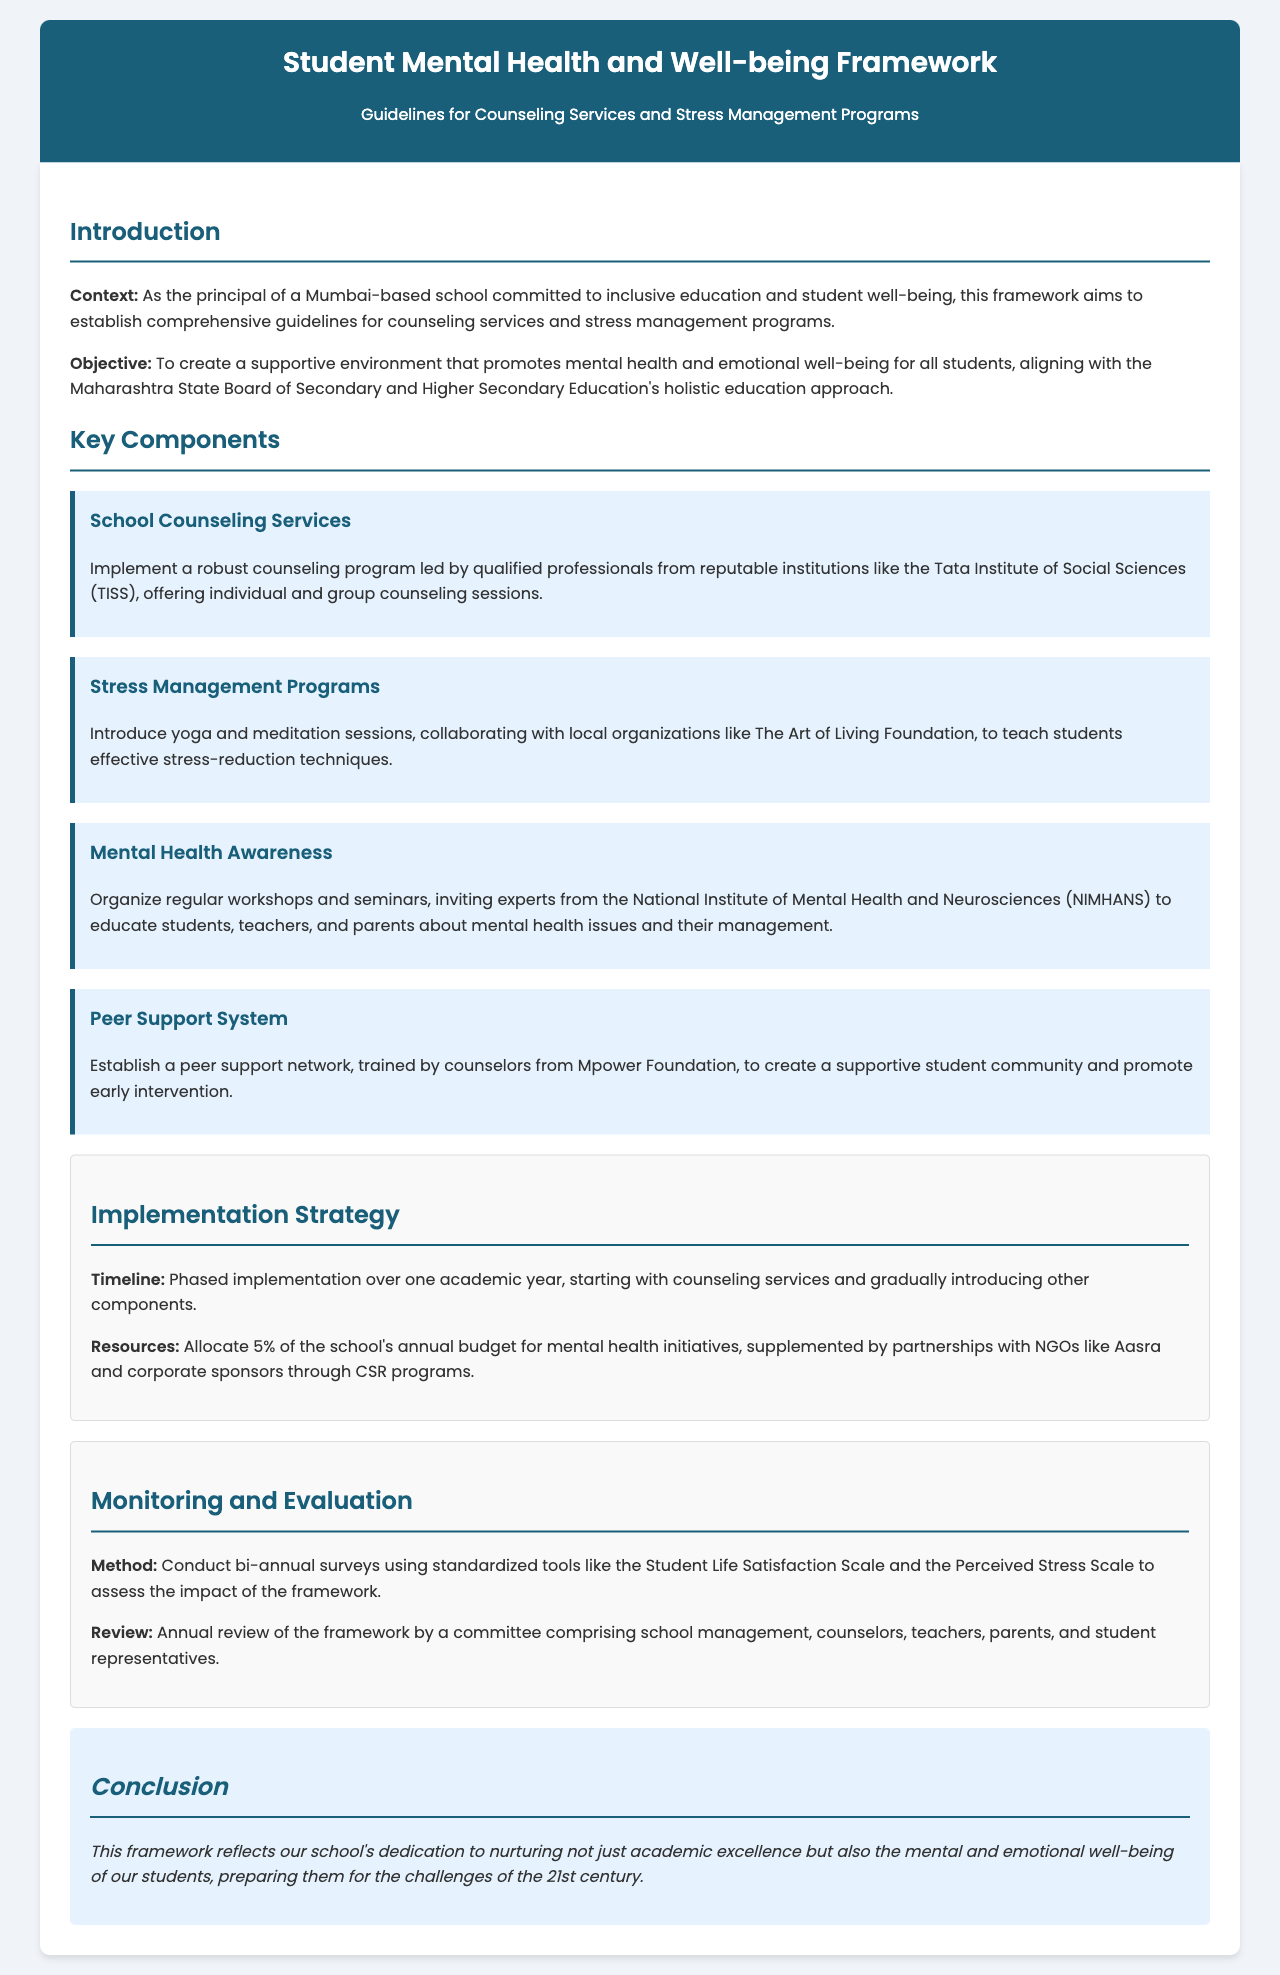What is the main objective of the framework? The main objective of the framework is to create a supportive environment that promotes mental health and emotional well-being for all students.
Answer: Supportive environment for mental health Which institution is mentioned for leading the counseling program? The document states that the counseling program should be led by qualified professionals from reputable institutions like the Tata Institute of Social Sciences (TISS).
Answer: Tata Institute of Social Sciences What is the name of the local organization mentioned for stress management programs? The framework mentions collaborating with local organizations like The Art of Living Foundation to introduce yoga and meditation sessions.
Answer: The Art of Living Foundation What percentage of the annual budget is allocated for mental health initiatives? The document specifies that 5% of the school's annual budget should be allocated for mental health initiatives.
Answer: 5% How often will surveys be conducted to assess the framework's impact? The document notes that bi-annual surveys will be conducted using standardized tools to assess the impact of the framework.
Answer: Bi-annual What is a key component of the framework focused on student community? A significant component mentioned is the establishment of a peer support network, trained by counselors from Mpower Foundation.
Answer: Peer support network Who will be involved in the annual review of the framework? The document states that the annual review will involve a committee comprising school management, counselors, teachers, parents, and student representatives.
Answer: School management, counselors, teachers, parents, and students What types of sessions are included in stress management programs? The document describes yoga and meditation sessions as part of the introduced stress management programs.
Answer: Yoga and meditation sessions 